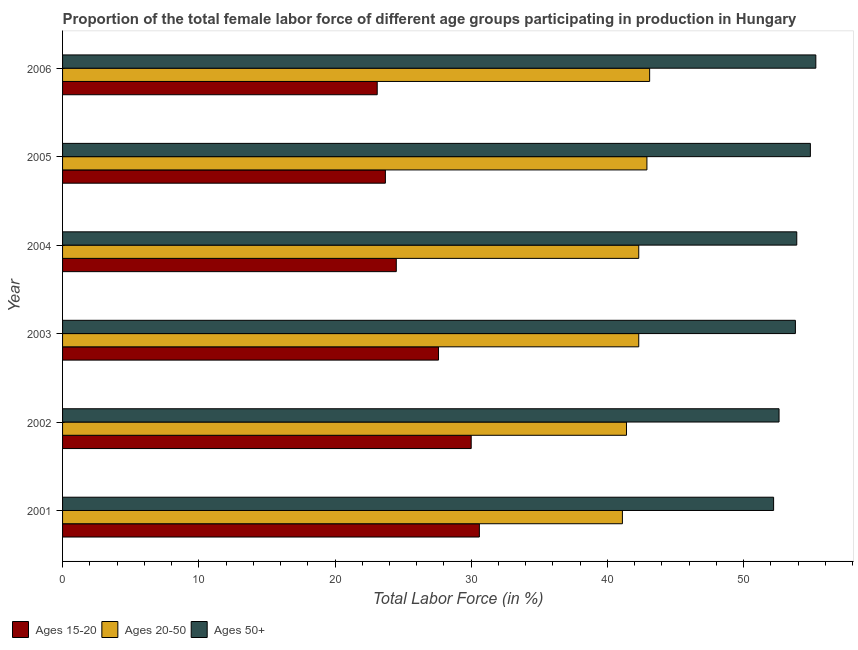How many different coloured bars are there?
Offer a terse response. 3. How many groups of bars are there?
Keep it short and to the point. 6. Are the number of bars on each tick of the Y-axis equal?
Ensure brevity in your answer.  Yes. How many bars are there on the 2nd tick from the bottom?
Ensure brevity in your answer.  3. What is the label of the 6th group of bars from the top?
Offer a terse response. 2001. What is the percentage of female labor force within the age group 20-50 in 2006?
Your answer should be very brief. 43.1. Across all years, what is the maximum percentage of female labor force above age 50?
Offer a very short reply. 55.3. Across all years, what is the minimum percentage of female labor force within the age group 15-20?
Keep it short and to the point. 23.1. In which year was the percentage of female labor force within the age group 15-20 maximum?
Keep it short and to the point. 2001. What is the total percentage of female labor force within the age group 20-50 in the graph?
Ensure brevity in your answer.  253.1. What is the difference between the percentage of female labor force within the age group 20-50 in 2001 and that in 2003?
Offer a very short reply. -1.2. What is the difference between the percentage of female labor force within the age group 15-20 in 2002 and the percentage of female labor force within the age group 20-50 in 2004?
Offer a terse response. -12.3. What is the average percentage of female labor force above age 50 per year?
Offer a very short reply. 53.78. In the year 2002, what is the difference between the percentage of female labor force within the age group 20-50 and percentage of female labor force within the age group 15-20?
Provide a succinct answer. 11.4. In how many years, is the percentage of female labor force within the age group 15-20 greater than 16 %?
Give a very brief answer. 6. What is the ratio of the percentage of female labor force within the age group 20-50 in 2004 to that in 2006?
Keep it short and to the point. 0.98. Is the difference between the percentage of female labor force above age 50 in 2002 and 2006 greater than the difference between the percentage of female labor force within the age group 20-50 in 2002 and 2006?
Give a very brief answer. No. What is the difference between the highest and the second highest percentage of female labor force above age 50?
Your answer should be very brief. 0.4. Is the sum of the percentage of female labor force within the age group 20-50 in 2003 and 2005 greater than the maximum percentage of female labor force above age 50 across all years?
Your answer should be compact. Yes. What does the 1st bar from the top in 2001 represents?
Provide a succinct answer. Ages 50+. What does the 2nd bar from the bottom in 2005 represents?
Provide a short and direct response. Ages 20-50. How many bars are there?
Ensure brevity in your answer.  18. Are the values on the major ticks of X-axis written in scientific E-notation?
Make the answer very short. No. Does the graph contain any zero values?
Make the answer very short. No. What is the title of the graph?
Give a very brief answer. Proportion of the total female labor force of different age groups participating in production in Hungary. What is the Total Labor Force (in %) in Ages 15-20 in 2001?
Keep it short and to the point. 30.6. What is the Total Labor Force (in %) in Ages 20-50 in 2001?
Give a very brief answer. 41.1. What is the Total Labor Force (in %) of Ages 50+ in 2001?
Offer a terse response. 52.2. What is the Total Labor Force (in %) of Ages 15-20 in 2002?
Provide a succinct answer. 30. What is the Total Labor Force (in %) of Ages 20-50 in 2002?
Keep it short and to the point. 41.4. What is the Total Labor Force (in %) of Ages 50+ in 2002?
Your answer should be very brief. 52.6. What is the Total Labor Force (in %) in Ages 15-20 in 2003?
Your response must be concise. 27.6. What is the Total Labor Force (in %) of Ages 20-50 in 2003?
Your answer should be very brief. 42.3. What is the Total Labor Force (in %) of Ages 50+ in 2003?
Ensure brevity in your answer.  53.8. What is the Total Labor Force (in %) in Ages 15-20 in 2004?
Make the answer very short. 24.5. What is the Total Labor Force (in %) of Ages 20-50 in 2004?
Keep it short and to the point. 42.3. What is the Total Labor Force (in %) in Ages 50+ in 2004?
Provide a succinct answer. 53.9. What is the Total Labor Force (in %) of Ages 15-20 in 2005?
Keep it short and to the point. 23.7. What is the Total Labor Force (in %) of Ages 20-50 in 2005?
Provide a short and direct response. 42.9. What is the Total Labor Force (in %) of Ages 50+ in 2005?
Your response must be concise. 54.9. What is the Total Labor Force (in %) in Ages 15-20 in 2006?
Provide a succinct answer. 23.1. What is the Total Labor Force (in %) of Ages 20-50 in 2006?
Offer a very short reply. 43.1. What is the Total Labor Force (in %) in Ages 50+ in 2006?
Offer a very short reply. 55.3. Across all years, what is the maximum Total Labor Force (in %) in Ages 15-20?
Your answer should be compact. 30.6. Across all years, what is the maximum Total Labor Force (in %) of Ages 20-50?
Offer a very short reply. 43.1. Across all years, what is the maximum Total Labor Force (in %) of Ages 50+?
Your answer should be compact. 55.3. Across all years, what is the minimum Total Labor Force (in %) in Ages 15-20?
Your answer should be compact. 23.1. Across all years, what is the minimum Total Labor Force (in %) of Ages 20-50?
Ensure brevity in your answer.  41.1. Across all years, what is the minimum Total Labor Force (in %) in Ages 50+?
Keep it short and to the point. 52.2. What is the total Total Labor Force (in %) in Ages 15-20 in the graph?
Your response must be concise. 159.5. What is the total Total Labor Force (in %) in Ages 20-50 in the graph?
Your response must be concise. 253.1. What is the total Total Labor Force (in %) in Ages 50+ in the graph?
Your response must be concise. 322.7. What is the difference between the Total Labor Force (in %) of Ages 15-20 in 2001 and that in 2002?
Your answer should be compact. 0.6. What is the difference between the Total Labor Force (in %) in Ages 50+ in 2001 and that in 2002?
Your answer should be compact. -0.4. What is the difference between the Total Labor Force (in %) of Ages 15-20 in 2001 and that in 2003?
Give a very brief answer. 3. What is the difference between the Total Labor Force (in %) in Ages 20-50 in 2001 and that in 2003?
Give a very brief answer. -1.2. What is the difference between the Total Labor Force (in %) of Ages 15-20 in 2001 and that in 2004?
Your answer should be compact. 6.1. What is the difference between the Total Labor Force (in %) in Ages 15-20 in 2001 and that in 2005?
Offer a terse response. 6.9. What is the difference between the Total Labor Force (in %) of Ages 20-50 in 2001 and that in 2005?
Provide a short and direct response. -1.8. What is the difference between the Total Labor Force (in %) in Ages 50+ in 2001 and that in 2005?
Offer a terse response. -2.7. What is the difference between the Total Labor Force (in %) in Ages 15-20 in 2001 and that in 2006?
Keep it short and to the point. 7.5. What is the difference between the Total Labor Force (in %) of Ages 15-20 in 2002 and that in 2003?
Ensure brevity in your answer.  2.4. What is the difference between the Total Labor Force (in %) of Ages 20-50 in 2002 and that in 2003?
Provide a short and direct response. -0.9. What is the difference between the Total Labor Force (in %) in Ages 50+ in 2002 and that in 2003?
Your answer should be very brief. -1.2. What is the difference between the Total Labor Force (in %) in Ages 50+ in 2002 and that in 2004?
Ensure brevity in your answer.  -1.3. What is the difference between the Total Labor Force (in %) of Ages 15-20 in 2002 and that in 2005?
Give a very brief answer. 6.3. What is the difference between the Total Labor Force (in %) in Ages 20-50 in 2002 and that in 2005?
Offer a terse response. -1.5. What is the difference between the Total Labor Force (in %) of Ages 50+ in 2002 and that in 2005?
Your response must be concise. -2.3. What is the difference between the Total Labor Force (in %) of Ages 20-50 in 2003 and that in 2004?
Make the answer very short. 0. What is the difference between the Total Labor Force (in %) of Ages 15-20 in 2003 and that in 2005?
Provide a short and direct response. 3.9. What is the difference between the Total Labor Force (in %) in Ages 15-20 in 2004 and that in 2005?
Your answer should be very brief. 0.8. What is the difference between the Total Labor Force (in %) of Ages 20-50 in 2004 and that in 2005?
Offer a terse response. -0.6. What is the difference between the Total Labor Force (in %) in Ages 15-20 in 2004 and that in 2006?
Give a very brief answer. 1.4. What is the difference between the Total Labor Force (in %) of Ages 20-50 in 2005 and that in 2006?
Give a very brief answer. -0.2. What is the difference between the Total Labor Force (in %) in Ages 50+ in 2005 and that in 2006?
Offer a very short reply. -0.4. What is the difference between the Total Labor Force (in %) of Ages 20-50 in 2001 and the Total Labor Force (in %) of Ages 50+ in 2002?
Provide a short and direct response. -11.5. What is the difference between the Total Labor Force (in %) in Ages 15-20 in 2001 and the Total Labor Force (in %) in Ages 20-50 in 2003?
Give a very brief answer. -11.7. What is the difference between the Total Labor Force (in %) in Ages 15-20 in 2001 and the Total Labor Force (in %) in Ages 50+ in 2003?
Offer a very short reply. -23.2. What is the difference between the Total Labor Force (in %) of Ages 15-20 in 2001 and the Total Labor Force (in %) of Ages 20-50 in 2004?
Offer a very short reply. -11.7. What is the difference between the Total Labor Force (in %) of Ages 15-20 in 2001 and the Total Labor Force (in %) of Ages 50+ in 2004?
Provide a succinct answer. -23.3. What is the difference between the Total Labor Force (in %) in Ages 20-50 in 2001 and the Total Labor Force (in %) in Ages 50+ in 2004?
Your response must be concise. -12.8. What is the difference between the Total Labor Force (in %) of Ages 15-20 in 2001 and the Total Labor Force (in %) of Ages 50+ in 2005?
Keep it short and to the point. -24.3. What is the difference between the Total Labor Force (in %) in Ages 15-20 in 2001 and the Total Labor Force (in %) in Ages 20-50 in 2006?
Keep it short and to the point. -12.5. What is the difference between the Total Labor Force (in %) of Ages 15-20 in 2001 and the Total Labor Force (in %) of Ages 50+ in 2006?
Offer a very short reply. -24.7. What is the difference between the Total Labor Force (in %) of Ages 15-20 in 2002 and the Total Labor Force (in %) of Ages 20-50 in 2003?
Provide a short and direct response. -12.3. What is the difference between the Total Labor Force (in %) in Ages 15-20 in 2002 and the Total Labor Force (in %) in Ages 50+ in 2003?
Keep it short and to the point. -23.8. What is the difference between the Total Labor Force (in %) in Ages 20-50 in 2002 and the Total Labor Force (in %) in Ages 50+ in 2003?
Your answer should be compact. -12.4. What is the difference between the Total Labor Force (in %) in Ages 15-20 in 2002 and the Total Labor Force (in %) in Ages 50+ in 2004?
Your answer should be very brief. -23.9. What is the difference between the Total Labor Force (in %) of Ages 15-20 in 2002 and the Total Labor Force (in %) of Ages 50+ in 2005?
Provide a short and direct response. -24.9. What is the difference between the Total Labor Force (in %) of Ages 20-50 in 2002 and the Total Labor Force (in %) of Ages 50+ in 2005?
Your answer should be very brief. -13.5. What is the difference between the Total Labor Force (in %) of Ages 15-20 in 2002 and the Total Labor Force (in %) of Ages 20-50 in 2006?
Your answer should be very brief. -13.1. What is the difference between the Total Labor Force (in %) in Ages 15-20 in 2002 and the Total Labor Force (in %) in Ages 50+ in 2006?
Provide a short and direct response. -25.3. What is the difference between the Total Labor Force (in %) of Ages 15-20 in 2003 and the Total Labor Force (in %) of Ages 20-50 in 2004?
Your answer should be very brief. -14.7. What is the difference between the Total Labor Force (in %) of Ages 15-20 in 2003 and the Total Labor Force (in %) of Ages 50+ in 2004?
Your answer should be very brief. -26.3. What is the difference between the Total Labor Force (in %) of Ages 20-50 in 2003 and the Total Labor Force (in %) of Ages 50+ in 2004?
Provide a short and direct response. -11.6. What is the difference between the Total Labor Force (in %) in Ages 15-20 in 2003 and the Total Labor Force (in %) in Ages 20-50 in 2005?
Your answer should be very brief. -15.3. What is the difference between the Total Labor Force (in %) of Ages 15-20 in 2003 and the Total Labor Force (in %) of Ages 50+ in 2005?
Offer a terse response. -27.3. What is the difference between the Total Labor Force (in %) in Ages 20-50 in 2003 and the Total Labor Force (in %) in Ages 50+ in 2005?
Provide a succinct answer. -12.6. What is the difference between the Total Labor Force (in %) in Ages 15-20 in 2003 and the Total Labor Force (in %) in Ages 20-50 in 2006?
Ensure brevity in your answer.  -15.5. What is the difference between the Total Labor Force (in %) of Ages 15-20 in 2003 and the Total Labor Force (in %) of Ages 50+ in 2006?
Make the answer very short. -27.7. What is the difference between the Total Labor Force (in %) of Ages 20-50 in 2003 and the Total Labor Force (in %) of Ages 50+ in 2006?
Give a very brief answer. -13. What is the difference between the Total Labor Force (in %) of Ages 15-20 in 2004 and the Total Labor Force (in %) of Ages 20-50 in 2005?
Your answer should be very brief. -18.4. What is the difference between the Total Labor Force (in %) in Ages 15-20 in 2004 and the Total Labor Force (in %) in Ages 50+ in 2005?
Your answer should be compact. -30.4. What is the difference between the Total Labor Force (in %) of Ages 20-50 in 2004 and the Total Labor Force (in %) of Ages 50+ in 2005?
Provide a short and direct response. -12.6. What is the difference between the Total Labor Force (in %) in Ages 15-20 in 2004 and the Total Labor Force (in %) in Ages 20-50 in 2006?
Ensure brevity in your answer.  -18.6. What is the difference between the Total Labor Force (in %) in Ages 15-20 in 2004 and the Total Labor Force (in %) in Ages 50+ in 2006?
Give a very brief answer. -30.8. What is the difference between the Total Labor Force (in %) of Ages 15-20 in 2005 and the Total Labor Force (in %) of Ages 20-50 in 2006?
Provide a short and direct response. -19.4. What is the difference between the Total Labor Force (in %) in Ages 15-20 in 2005 and the Total Labor Force (in %) in Ages 50+ in 2006?
Give a very brief answer. -31.6. What is the average Total Labor Force (in %) of Ages 15-20 per year?
Provide a short and direct response. 26.58. What is the average Total Labor Force (in %) in Ages 20-50 per year?
Offer a terse response. 42.18. What is the average Total Labor Force (in %) in Ages 50+ per year?
Provide a succinct answer. 53.78. In the year 2001, what is the difference between the Total Labor Force (in %) in Ages 15-20 and Total Labor Force (in %) in Ages 20-50?
Your answer should be very brief. -10.5. In the year 2001, what is the difference between the Total Labor Force (in %) in Ages 15-20 and Total Labor Force (in %) in Ages 50+?
Make the answer very short. -21.6. In the year 2001, what is the difference between the Total Labor Force (in %) in Ages 20-50 and Total Labor Force (in %) in Ages 50+?
Give a very brief answer. -11.1. In the year 2002, what is the difference between the Total Labor Force (in %) in Ages 15-20 and Total Labor Force (in %) in Ages 20-50?
Your response must be concise. -11.4. In the year 2002, what is the difference between the Total Labor Force (in %) in Ages 15-20 and Total Labor Force (in %) in Ages 50+?
Offer a very short reply. -22.6. In the year 2002, what is the difference between the Total Labor Force (in %) of Ages 20-50 and Total Labor Force (in %) of Ages 50+?
Keep it short and to the point. -11.2. In the year 2003, what is the difference between the Total Labor Force (in %) in Ages 15-20 and Total Labor Force (in %) in Ages 20-50?
Make the answer very short. -14.7. In the year 2003, what is the difference between the Total Labor Force (in %) in Ages 15-20 and Total Labor Force (in %) in Ages 50+?
Offer a very short reply. -26.2. In the year 2003, what is the difference between the Total Labor Force (in %) in Ages 20-50 and Total Labor Force (in %) in Ages 50+?
Your response must be concise. -11.5. In the year 2004, what is the difference between the Total Labor Force (in %) in Ages 15-20 and Total Labor Force (in %) in Ages 20-50?
Give a very brief answer. -17.8. In the year 2004, what is the difference between the Total Labor Force (in %) of Ages 15-20 and Total Labor Force (in %) of Ages 50+?
Your answer should be very brief. -29.4. In the year 2005, what is the difference between the Total Labor Force (in %) of Ages 15-20 and Total Labor Force (in %) of Ages 20-50?
Provide a short and direct response. -19.2. In the year 2005, what is the difference between the Total Labor Force (in %) of Ages 15-20 and Total Labor Force (in %) of Ages 50+?
Your response must be concise. -31.2. In the year 2005, what is the difference between the Total Labor Force (in %) in Ages 20-50 and Total Labor Force (in %) in Ages 50+?
Make the answer very short. -12. In the year 2006, what is the difference between the Total Labor Force (in %) in Ages 15-20 and Total Labor Force (in %) in Ages 50+?
Ensure brevity in your answer.  -32.2. In the year 2006, what is the difference between the Total Labor Force (in %) in Ages 20-50 and Total Labor Force (in %) in Ages 50+?
Your response must be concise. -12.2. What is the ratio of the Total Labor Force (in %) in Ages 15-20 in 2001 to that in 2002?
Offer a very short reply. 1.02. What is the ratio of the Total Labor Force (in %) in Ages 50+ in 2001 to that in 2002?
Your answer should be very brief. 0.99. What is the ratio of the Total Labor Force (in %) of Ages 15-20 in 2001 to that in 2003?
Offer a terse response. 1.11. What is the ratio of the Total Labor Force (in %) of Ages 20-50 in 2001 to that in 2003?
Offer a very short reply. 0.97. What is the ratio of the Total Labor Force (in %) of Ages 50+ in 2001 to that in 2003?
Your answer should be very brief. 0.97. What is the ratio of the Total Labor Force (in %) of Ages 15-20 in 2001 to that in 2004?
Your answer should be compact. 1.25. What is the ratio of the Total Labor Force (in %) in Ages 20-50 in 2001 to that in 2004?
Keep it short and to the point. 0.97. What is the ratio of the Total Labor Force (in %) in Ages 50+ in 2001 to that in 2004?
Ensure brevity in your answer.  0.97. What is the ratio of the Total Labor Force (in %) in Ages 15-20 in 2001 to that in 2005?
Keep it short and to the point. 1.29. What is the ratio of the Total Labor Force (in %) of Ages 20-50 in 2001 to that in 2005?
Your answer should be very brief. 0.96. What is the ratio of the Total Labor Force (in %) of Ages 50+ in 2001 to that in 2005?
Your answer should be compact. 0.95. What is the ratio of the Total Labor Force (in %) of Ages 15-20 in 2001 to that in 2006?
Provide a short and direct response. 1.32. What is the ratio of the Total Labor Force (in %) of Ages 20-50 in 2001 to that in 2006?
Provide a short and direct response. 0.95. What is the ratio of the Total Labor Force (in %) in Ages 50+ in 2001 to that in 2006?
Ensure brevity in your answer.  0.94. What is the ratio of the Total Labor Force (in %) in Ages 15-20 in 2002 to that in 2003?
Give a very brief answer. 1.09. What is the ratio of the Total Labor Force (in %) in Ages 20-50 in 2002 to that in 2003?
Offer a terse response. 0.98. What is the ratio of the Total Labor Force (in %) of Ages 50+ in 2002 to that in 2003?
Your answer should be very brief. 0.98. What is the ratio of the Total Labor Force (in %) in Ages 15-20 in 2002 to that in 2004?
Your answer should be compact. 1.22. What is the ratio of the Total Labor Force (in %) of Ages 20-50 in 2002 to that in 2004?
Your response must be concise. 0.98. What is the ratio of the Total Labor Force (in %) of Ages 50+ in 2002 to that in 2004?
Provide a short and direct response. 0.98. What is the ratio of the Total Labor Force (in %) of Ages 15-20 in 2002 to that in 2005?
Keep it short and to the point. 1.27. What is the ratio of the Total Labor Force (in %) in Ages 50+ in 2002 to that in 2005?
Your answer should be compact. 0.96. What is the ratio of the Total Labor Force (in %) of Ages 15-20 in 2002 to that in 2006?
Give a very brief answer. 1.3. What is the ratio of the Total Labor Force (in %) in Ages 20-50 in 2002 to that in 2006?
Ensure brevity in your answer.  0.96. What is the ratio of the Total Labor Force (in %) in Ages 50+ in 2002 to that in 2006?
Your answer should be compact. 0.95. What is the ratio of the Total Labor Force (in %) in Ages 15-20 in 2003 to that in 2004?
Give a very brief answer. 1.13. What is the ratio of the Total Labor Force (in %) of Ages 20-50 in 2003 to that in 2004?
Offer a terse response. 1. What is the ratio of the Total Labor Force (in %) of Ages 50+ in 2003 to that in 2004?
Your answer should be very brief. 1. What is the ratio of the Total Labor Force (in %) in Ages 15-20 in 2003 to that in 2005?
Your answer should be compact. 1.16. What is the ratio of the Total Labor Force (in %) of Ages 20-50 in 2003 to that in 2005?
Ensure brevity in your answer.  0.99. What is the ratio of the Total Labor Force (in %) of Ages 50+ in 2003 to that in 2005?
Provide a succinct answer. 0.98. What is the ratio of the Total Labor Force (in %) in Ages 15-20 in 2003 to that in 2006?
Offer a terse response. 1.19. What is the ratio of the Total Labor Force (in %) in Ages 20-50 in 2003 to that in 2006?
Give a very brief answer. 0.98. What is the ratio of the Total Labor Force (in %) in Ages 50+ in 2003 to that in 2006?
Ensure brevity in your answer.  0.97. What is the ratio of the Total Labor Force (in %) of Ages 15-20 in 2004 to that in 2005?
Offer a very short reply. 1.03. What is the ratio of the Total Labor Force (in %) of Ages 20-50 in 2004 to that in 2005?
Provide a succinct answer. 0.99. What is the ratio of the Total Labor Force (in %) of Ages 50+ in 2004 to that in 2005?
Make the answer very short. 0.98. What is the ratio of the Total Labor Force (in %) in Ages 15-20 in 2004 to that in 2006?
Offer a terse response. 1.06. What is the ratio of the Total Labor Force (in %) of Ages 20-50 in 2004 to that in 2006?
Your answer should be very brief. 0.98. What is the ratio of the Total Labor Force (in %) in Ages 50+ in 2004 to that in 2006?
Offer a very short reply. 0.97. What is the ratio of the Total Labor Force (in %) in Ages 15-20 in 2005 to that in 2006?
Make the answer very short. 1.03. What is the difference between the highest and the second highest Total Labor Force (in %) of Ages 15-20?
Provide a succinct answer. 0.6. What is the difference between the highest and the lowest Total Labor Force (in %) in Ages 50+?
Your answer should be compact. 3.1. 